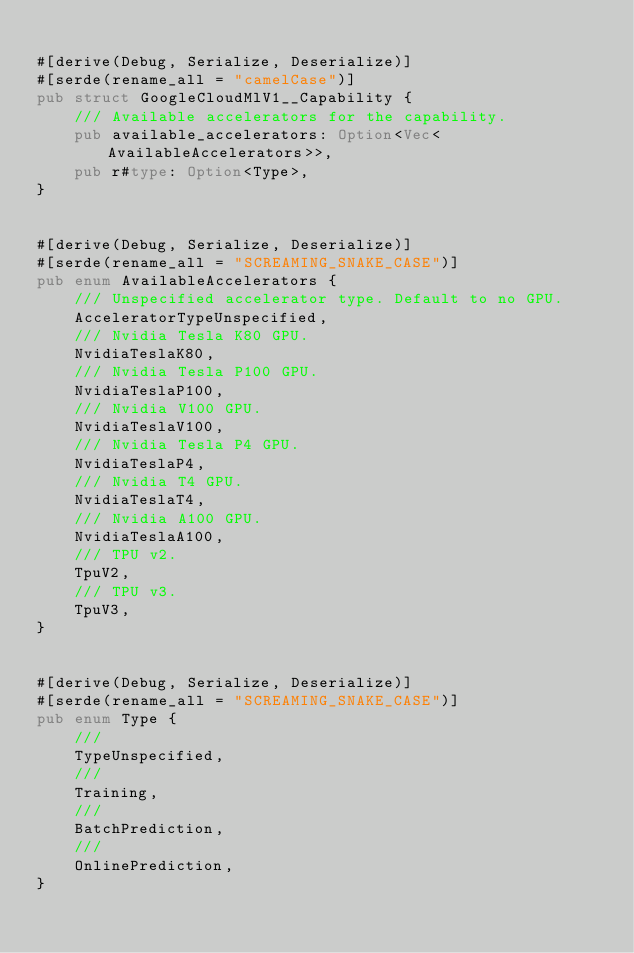Convert code to text. <code><loc_0><loc_0><loc_500><loc_500><_Rust_>
#[derive(Debug, Serialize, Deserialize)]
#[serde(rename_all = "camelCase")]
pub struct GoogleCloudMlV1__Capability {
	/// Available accelerators for the capability.
	pub available_accelerators: Option<Vec<AvailableAccelerators>>,
	pub r#type: Option<Type>,
}


#[derive(Debug, Serialize, Deserialize)]
#[serde(rename_all = "SCREAMING_SNAKE_CASE")]
pub enum AvailableAccelerators {
	/// Unspecified accelerator type. Default to no GPU.
	AcceleratorTypeUnspecified,
	/// Nvidia Tesla K80 GPU.
	NvidiaTeslaK80,
	/// Nvidia Tesla P100 GPU.
	NvidiaTeslaP100,
	/// Nvidia V100 GPU.
	NvidiaTeslaV100,
	/// Nvidia Tesla P4 GPU.
	NvidiaTeslaP4,
	/// Nvidia T4 GPU.
	NvidiaTeslaT4,
	/// Nvidia A100 GPU.
	NvidiaTeslaA100,
	/// TPU v2.
	TpuV2,
	/// TPU v3.
	TpuV3,
}


#[derive(Debug, Serialize, Deserialize)]
#[serde(rename_all = "SCREAMING_SNAKE_CASE")]
pub enum Type {
	/// 
	TypeUnspecified,
	/// 
	Training,
	/// 
	BatchPrediction,
	/// 
	OnlinePrediction,
}


</code> 